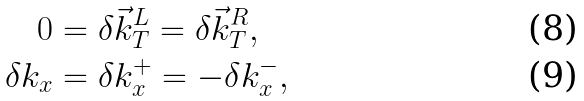Convert formula to latex. <formula><loc_0><loc_0><loc_500><loc_500>0 & = \delta { \vec { k } } _ { T } ^ { L } = \delta { \vec { k } } _ { T } ^ { R } , \\ \delta k _ { x } & = \delta k _ { x } ^ { + } = - \delta k _ { x } ^ { - } ,</formula> 